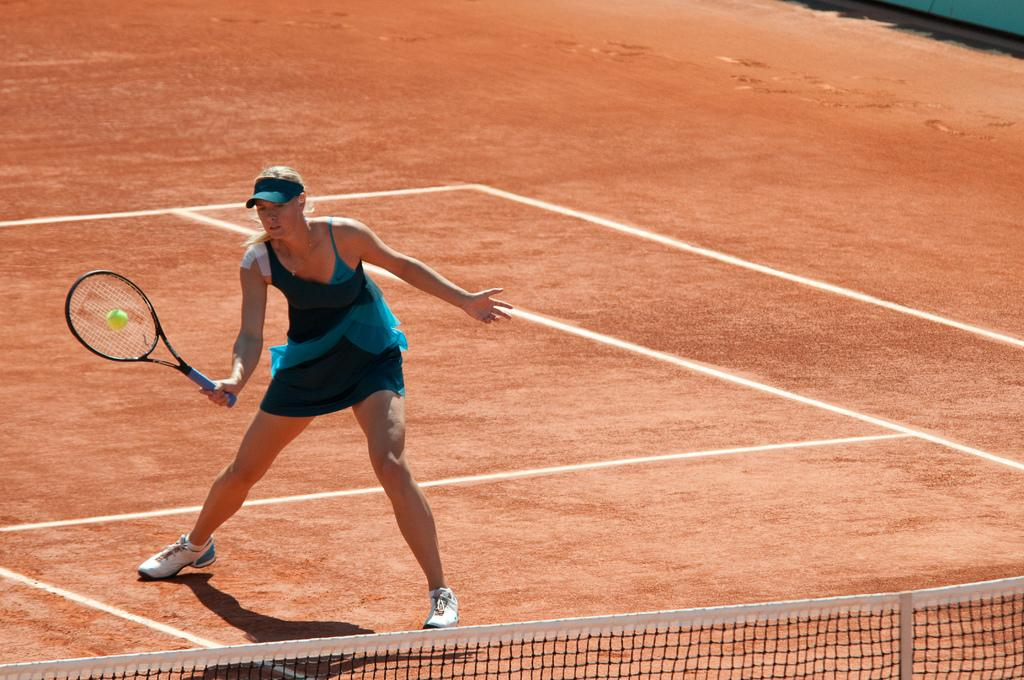What is the person in the image doing? The person is playing a game on the ground. What is the person wearing? The person is wearing a skirt and cap. What can be seen at the bottom of the image? There is a fence at the bottom of the image. Who else is present in the image? There is a woman holding a bat in the image. What object is involved in the game being played? There is a ball in the image. Can you tell me how many airplanes are flying in the image? There are no airplanes visible in the image. What type of holiday is the person celebrating in the image? There is no indication of a holiday being celebrated in the image. 